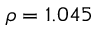Convert formula to latex. <formula><loc_0><loc_0><loc_500><loc_500>\rho = 1 . 0 4 5</formula> 